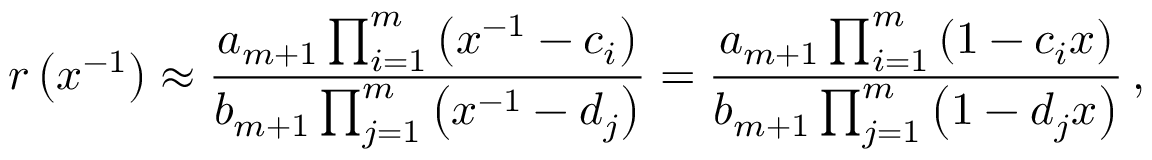Convert formula to latex. <formula><loc_0><loc_0><loc_500><loc_500>r \left ( x ^ { - 1 } \right ) \approx \frac { a _ { m + 1 } \prod _ { i = 1 } ^ { m } \left ( x ^ { - 1 } - c _ { i } \right ) } { b _ { m + 1 } \prod _ { j = 1 } ^ { m } \left ( x ^ { - 1 } - d _ { j } \right ) } = \frac { a _ { m + 1 } \prod _ { i = 1 } ^ { m } \left ( 1 - c _ { i } x \right ) } { b _ { m + 1 } \prod _ { j = 1 } ^ { m } \left ( 1 - d _ { j } x \right ) } \, ,</formula> 